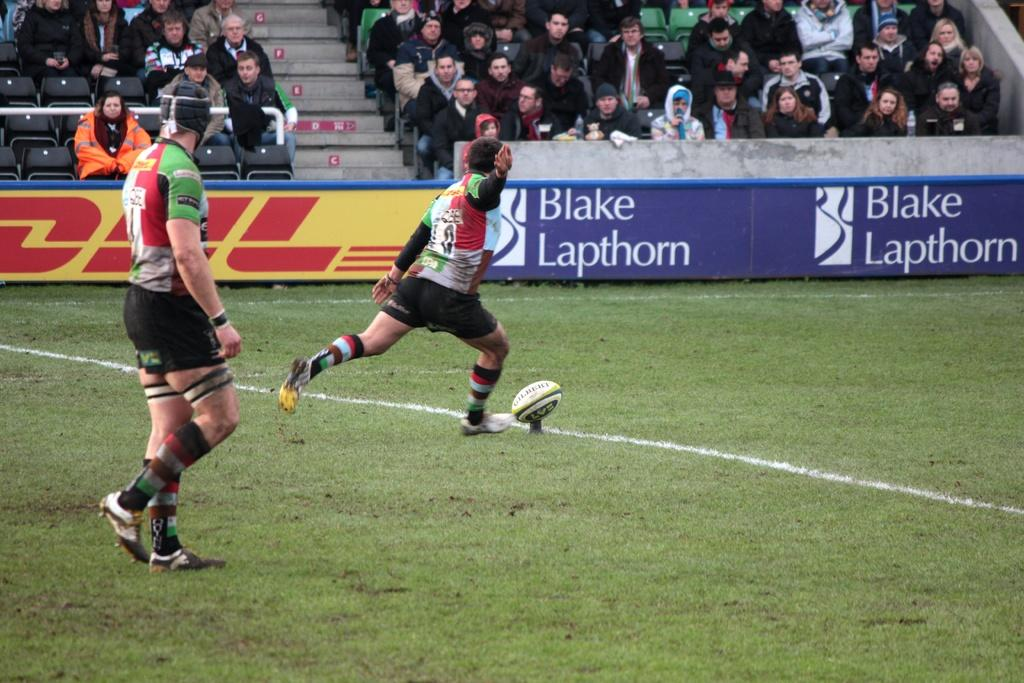Provide a one-sentence caption for the provided image. A player gets ready to kick the ball in front of a sign for Black Lapthorn. 